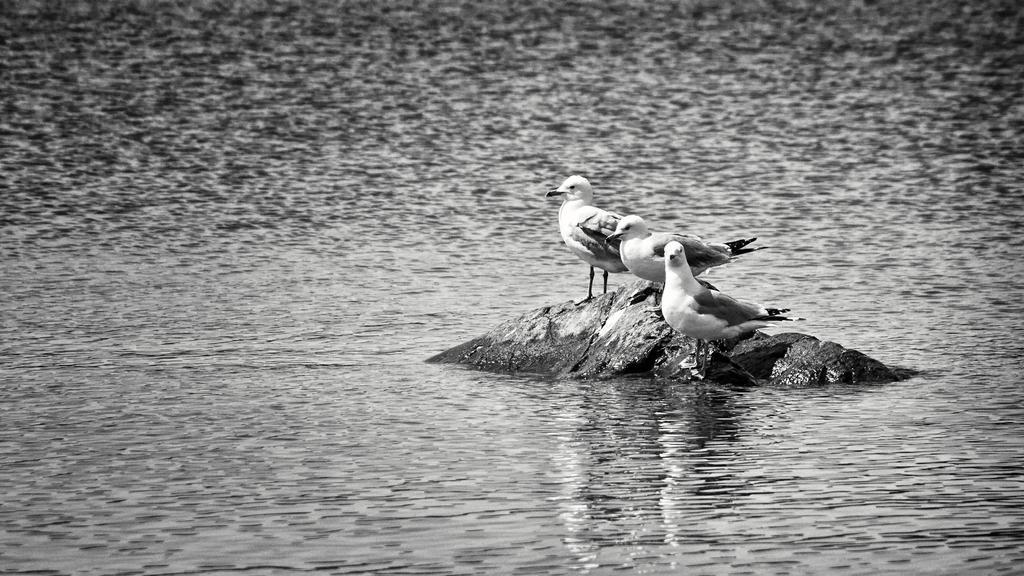How would you summarize this image in a sentence or two? In this image we can see some birds which are on the stone in the middle of water and in the background of the image we can see water. 